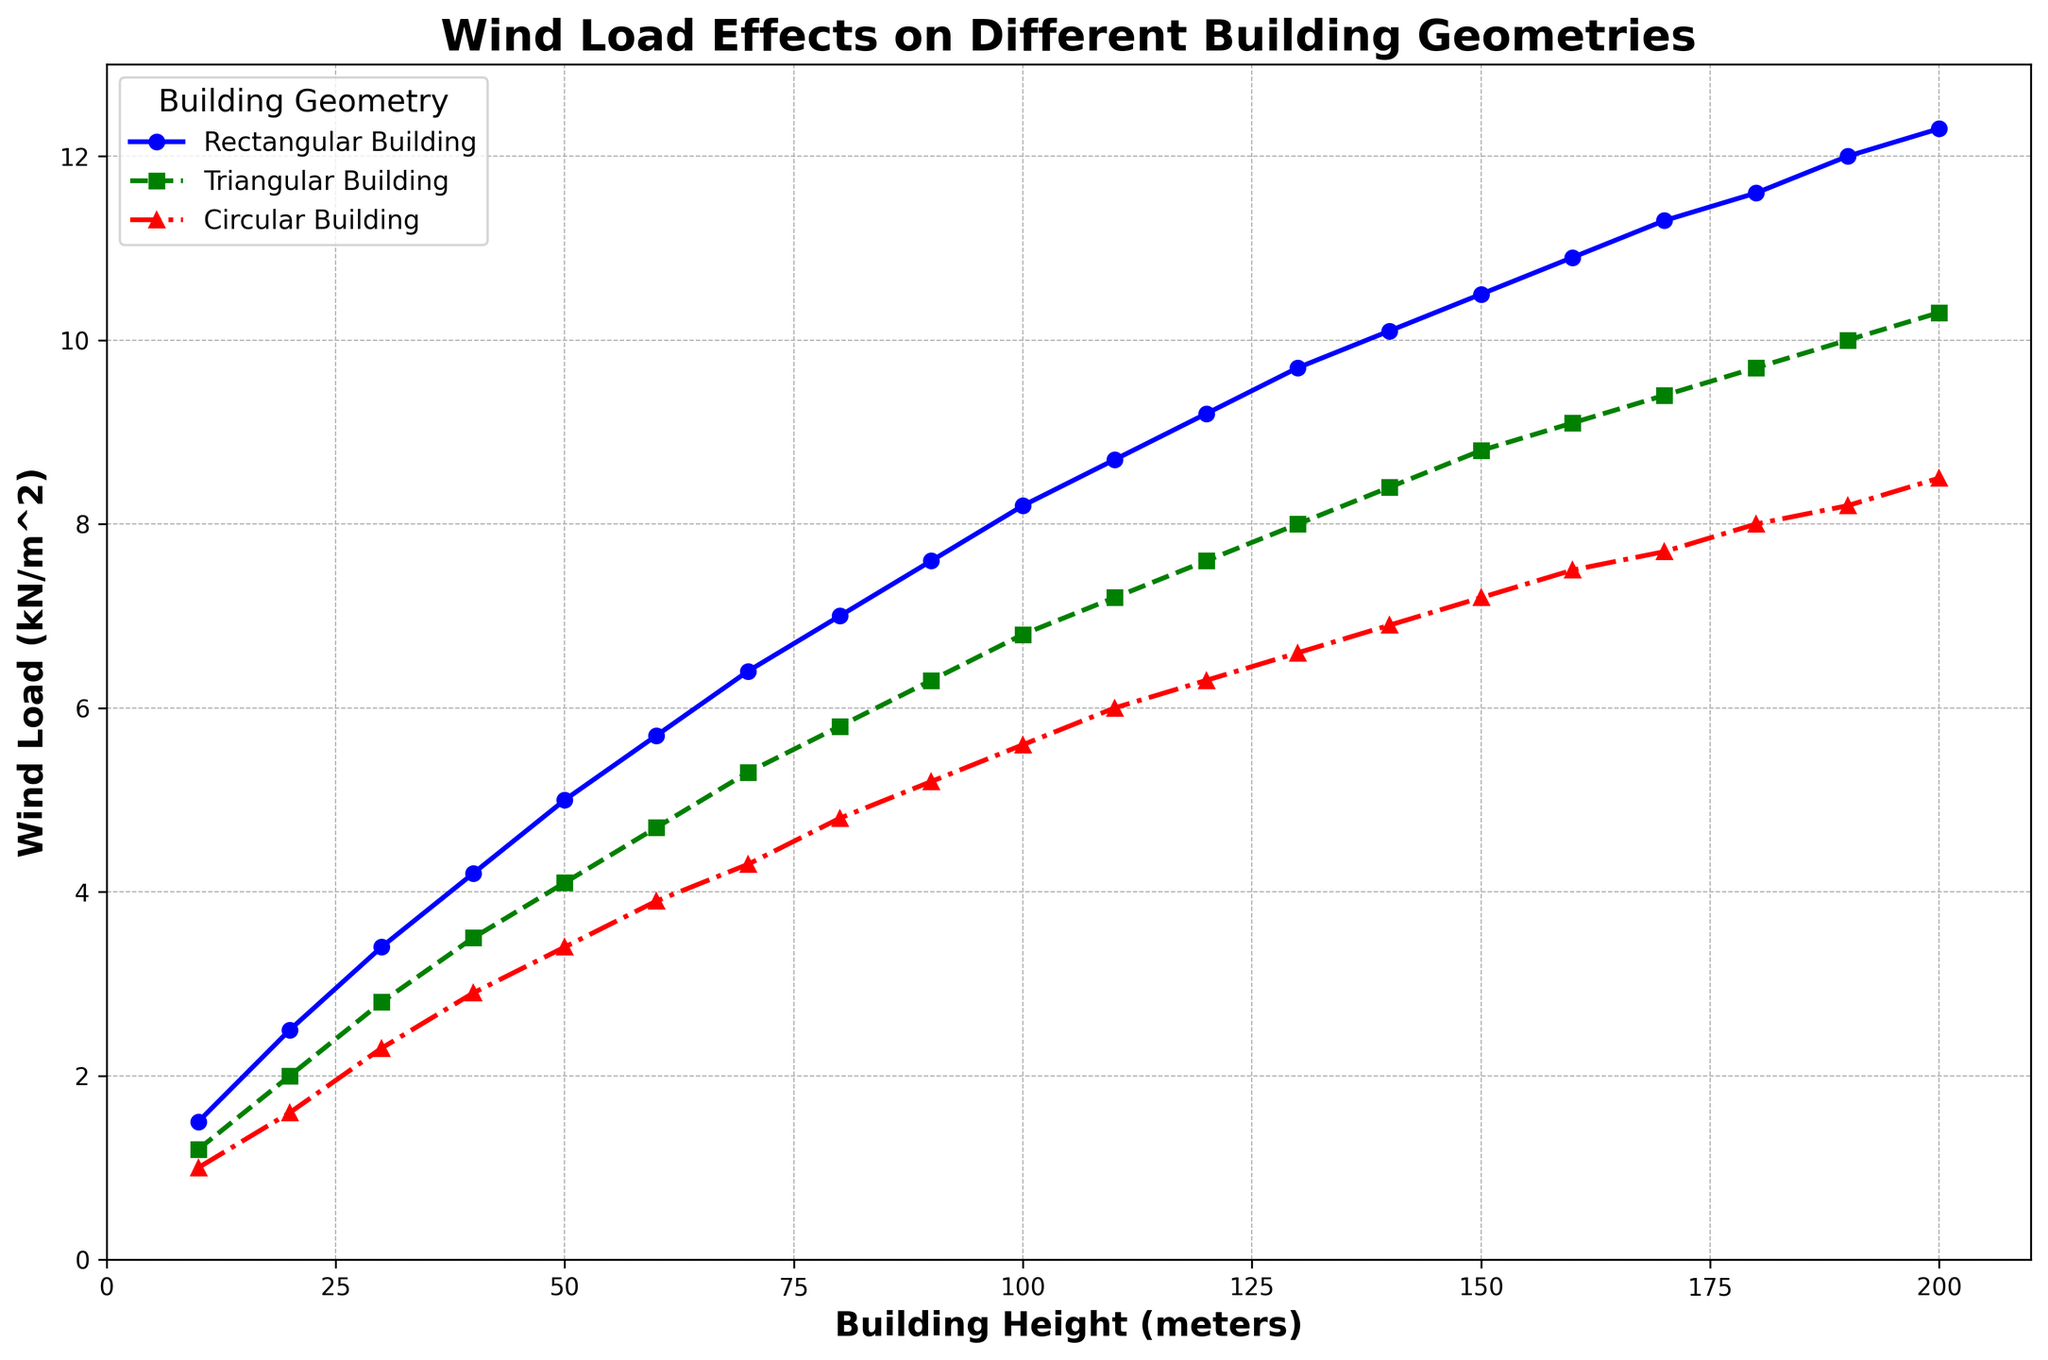What type of building geometry experiences the highest wind load at a height of 100 meters? The highest wind load at 100 meters can be observed by looking for the tallest marker at this height. The blue marker (Rectangular Building) is the tallest, indicating the highest wind load.
Answer: Rectangular Building At what height does the Circular Building experience a wind load of approximately 3.9 kN/m^2? To find this, look for the red markers along the y-axis at 3.9 kN/m^2. The corresponding x-value (height) is around 60 meters.
Answer: 60 meters What is the difference in wind load between the Rectangular Building and Triangular Building at 150 meters? At 150 meters, the wind loads for Rectangular and Triangular Buildings are approximately 10.5 and 8.8 kN/m^2 respectively. The difference is 10.5 - 8.8.
Answer: 1.7 kN/m^2 At what height does the Triangular Building's wind load first exceed 5 kN/m^2? Look for the first green marker above the 5 kN/m^2 line on the y-axis. The x-value (height) at this point is approximately 70 meters.
Answer: 70 meters Which building geometry shows the least sensitivity to increase in height in terms of wind load? To determine sensitivity, observe the slopes of the plot lines. The red (Circular Building) line has the smallest slope, indicating the least sensitivity to height increase.
Answer: Circular Building What is the wind load for the Rectangular Building at a height of 200 meters, and how does it compare to the Circular Building at the same height? At 200 meters, the wind load for Rectangular and Circular Buildings is approximately 12.3 and 8.5 kN/m^2 respectively. Comparison shows Rectangular Building has a higher wind load.
Answer: Rectangular > Circular How much more wind load does the Triangular Building experience compared to the Circular Building at a height of 130 meters? At 130 meters, the wind load for Triangular and Circular Buildings is approximately 8.0 and 6.6 kN/m^2 respectively. The difference is 8.0 - 6.6.
Answer: 1.4 kN/m^2 On average, how much does the wind load increase per 10 meters of height for the Rectangular Building? The wind loads at 10 and 200 meters are 1.5 and 12.3 kN/m^2 respectively. The increase per 10 meters is (12.3 - 1.5) / (200 - 10) * 10.
Answer: 0.566 kN/m^2 Compare the wind load on the Circular Building at 40 meters to the Triangular Building at the same height. Is it higher or lower? At 40 meters, the wind loads for Circular and Triangular Buildings are approximately 2.9 and 3.5 kN/m^2 respectively. The Circular Building's load is lower.
Answer: Lower 